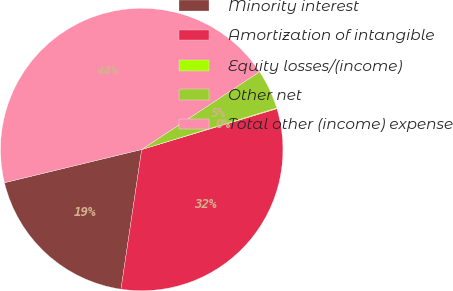Convert chart to OTSL. <chart><loc_0><loc_0><loc_500><loc_500><pie_chart><fcel>Minority interest<fcel>Amortization of intangible<fcel>Equity losses/(income)<fcel>Other net<fcel>Total other (income) expense<nl><fcel>18.88%<fcel>32.01%<fcel>0.09%<fcel>4.53%<fcel>44.49%<nl></chart> 